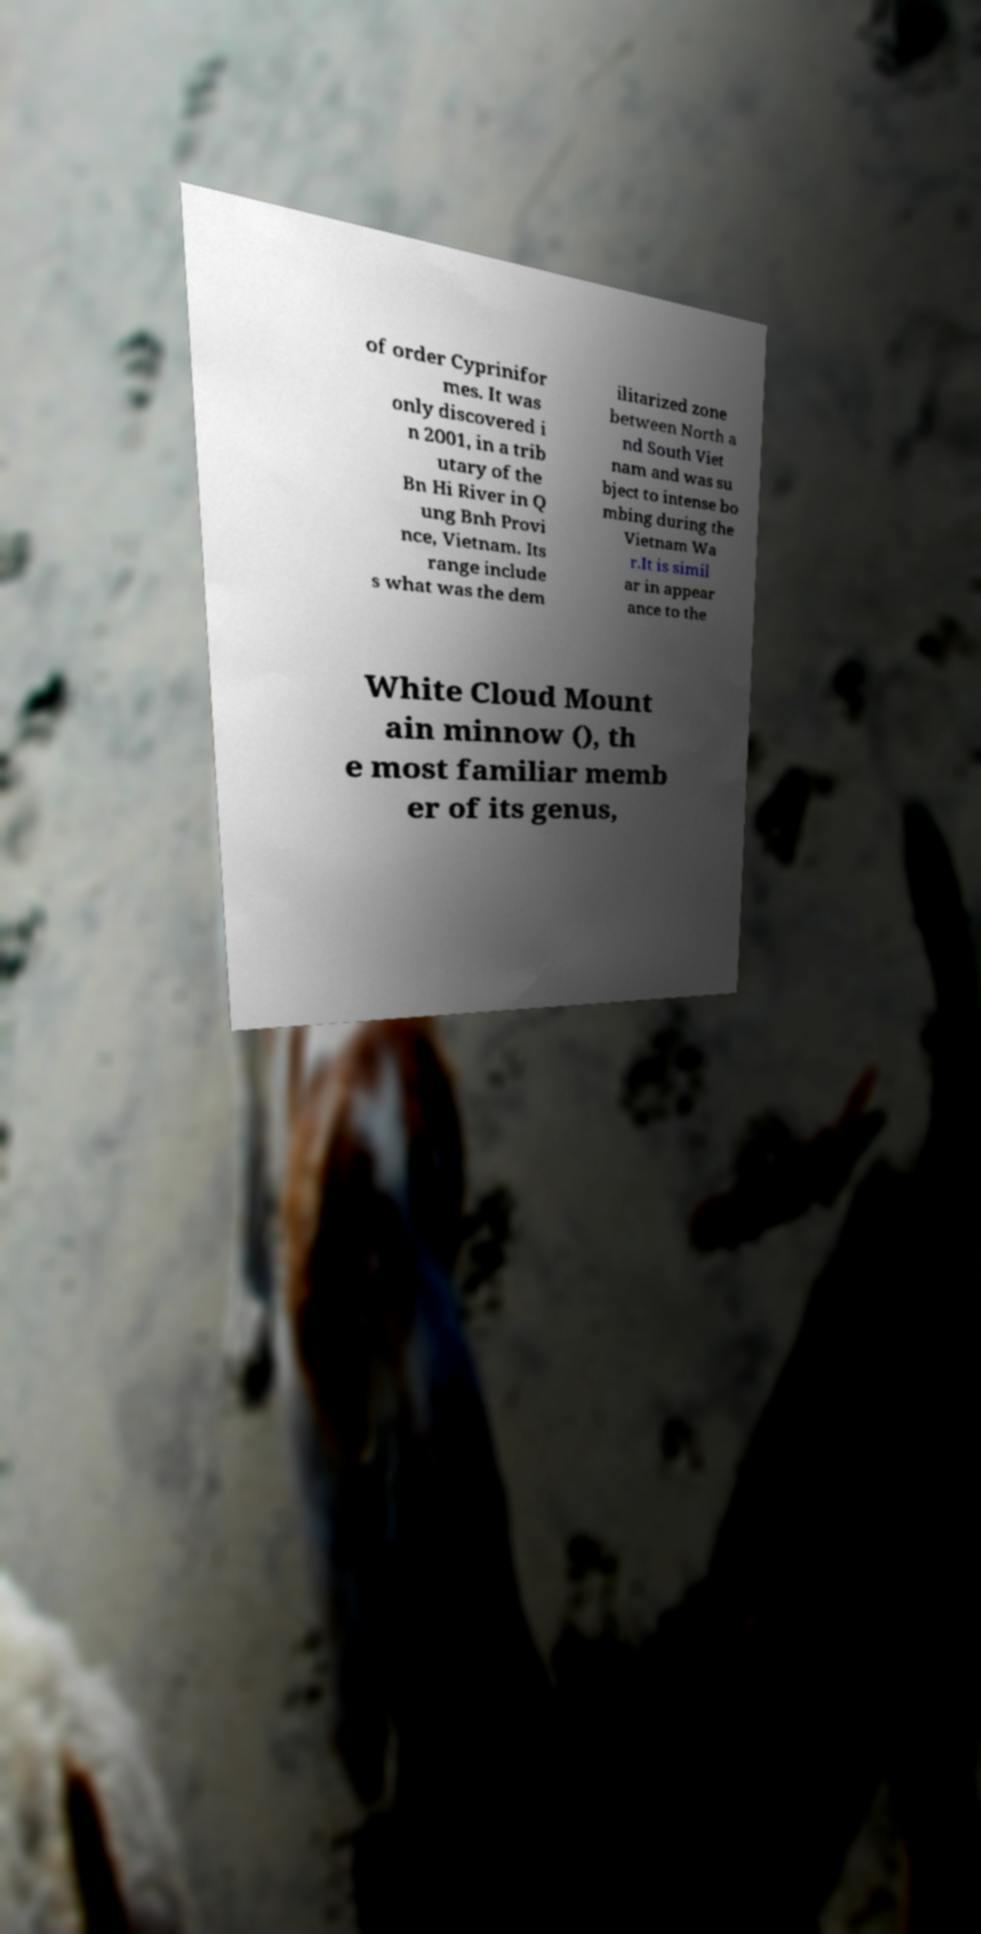What messages or text are displayed in this image? I need them in a readable, typed format. of order Cyprinifor mes. It was only discovered i n 2001, in a trib utary of the Bn Hi River in Q ung Bnh Provi nce, Vietnam. Its range include s what was the dem ilitarized zone between North a nd South Viet nam and was su bject to intense bo mbing during the Vietnam Wa r.It is simil ar in appear ance to the White Cloud Mount ain minnow (), th e most familiar memb er of its genus, 